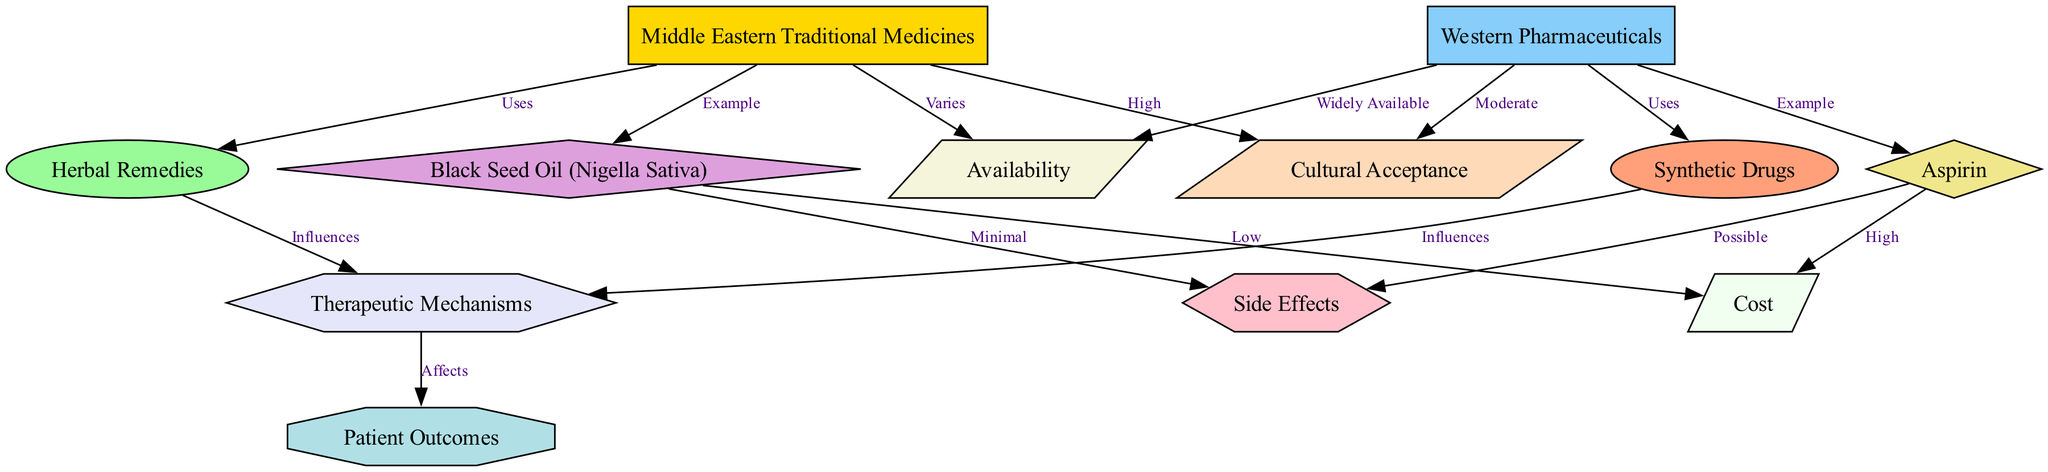What are the two main categories of medicines represented in the diagram? The diagram clearly delineates two categories of medicines, which are "Middle Eastern Traditional Medicines" and "Western Pharmaceuticals." These are the two primary nodes that form the foundation of the comparative analysis in the diagram.
Answer: Middle Eastern Traditional Medicines and Western Pharmaceuticals How many examples of medicines are provided in the diagram? The diagram includes two examples: "Black Seed Oil (Nigella Sativa)" for Middle Eastern Traditional Medicines and "Aspirin" for Western Pharmaceuticals. These examples are directly connected to their respective categories, indicating two examples in total.
Answer: 2 Which medicine has minimal side effects according to the diagram? The diagram points out that “Black Seed Oil (Nigella Sativa)” has "Minimal" side effects, as indicated by the edge connecting this medicine to the "Side Effects" node.
Answer: Black Seed Oil (Nigella Sativa) What factors influence therapeutic mechanisms for both categories of medicines? The diagram illustrates that both "Herbal Remedies" and "Synthetic Drugs" influence "Therapeutic Mechanisms." This indicates that both categories of medicines share a commonality in how the therapeutic mechanisms are defined or affected by their respective medicines.
Answer: Herbal Remedies and Synthetic Drugs Which category of medicines is widely available? In the diagram, it is noted that "Western Pharmaceuticals" are "Widely Available." This is indicated by the connection from this category to the "Availability" node, denoting the greater accessibility of Western Pharmaceuticals compared to Middle Eastern Traditional Medicines, which vary in availability.
Answer: Western Pharmaceuticals What does the diagram indicate about the cultural acceptance of Middle Eastern Traditional Medicines? According to the diagram, “Cultural Acceptance” for "Middle Eastern Traditional Medicines" is labeled as "High," which suggests strong community support or use in their cultural context. This is in contrast to only "Moderate" cultural acceptance for Western Pharmaceuticals.
Answer: High What is the cost difference indicated in the diagram for the two medicines? The diagram specifies that "Black Seed Oil (Nigella Sativa)" has "Low" cost while "Aspirin" is associated with "High" cost. This clear differentiation emphasizes a significant cost gap between the two examples given within their respective categories.
Answer: Low and High How does the influence of therapeutic mechanisms affect patient outcomes? The diagram shows arrows indicating that both "Herbal Remedies" and "Synthetic Drugs" influence "Therapeutic Mechanisms," which in turn "Affects" "Patient Outcomes.” This sequential relationship highlights that both types of therapeutics directly feed into how outcomes for patients are determined.
Answer: Affects What is the connection between "Synthetic Drugs" and "Side Effects"? The diagram details that "Synthetic Drugs" are connected to "Side Effects" with the label "Possible," suggesting that while there may be side effects from synthetic pharmaceuticals, they are not as guaranteed or certain as those from other types, indicating a variable risk level.
Answer: Possible 